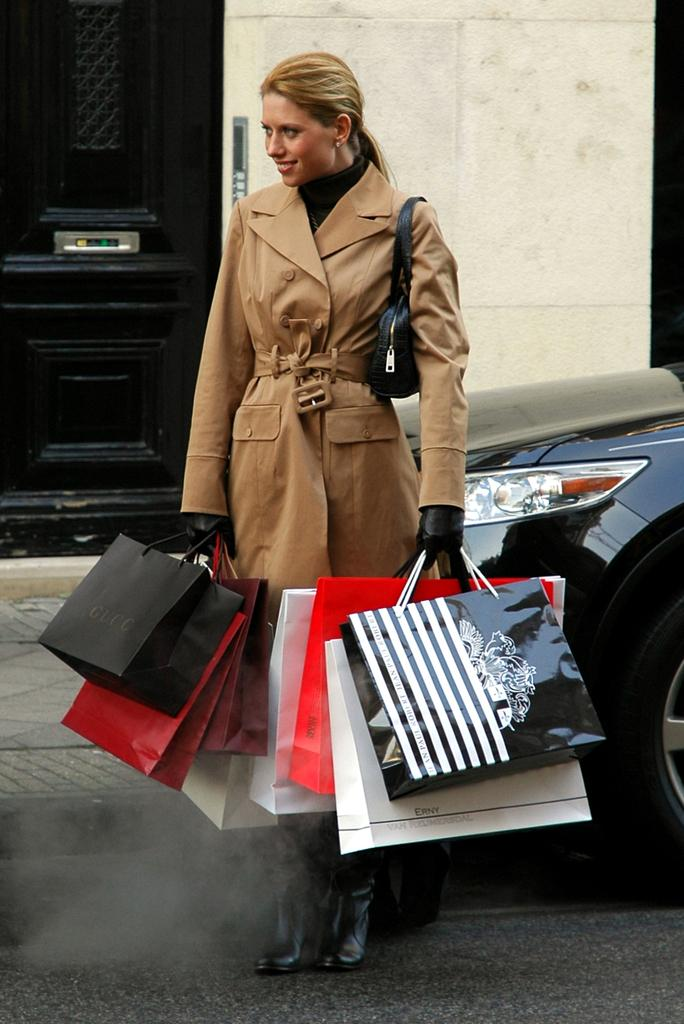Who is present in the image? There is a woman in the image. What is the woman holding in her hands? The woman is holding bags in her hands. What is the woman's facial expression? The woman is smiling. What can be seen in the background of the image? There is a car, a door, and a wall in the background of the image. What type of clover is growing on the woman's shoulder in the image? There is no clover present in the image; it only features a woman holding bags, a car, a door, and a wall in the background. 